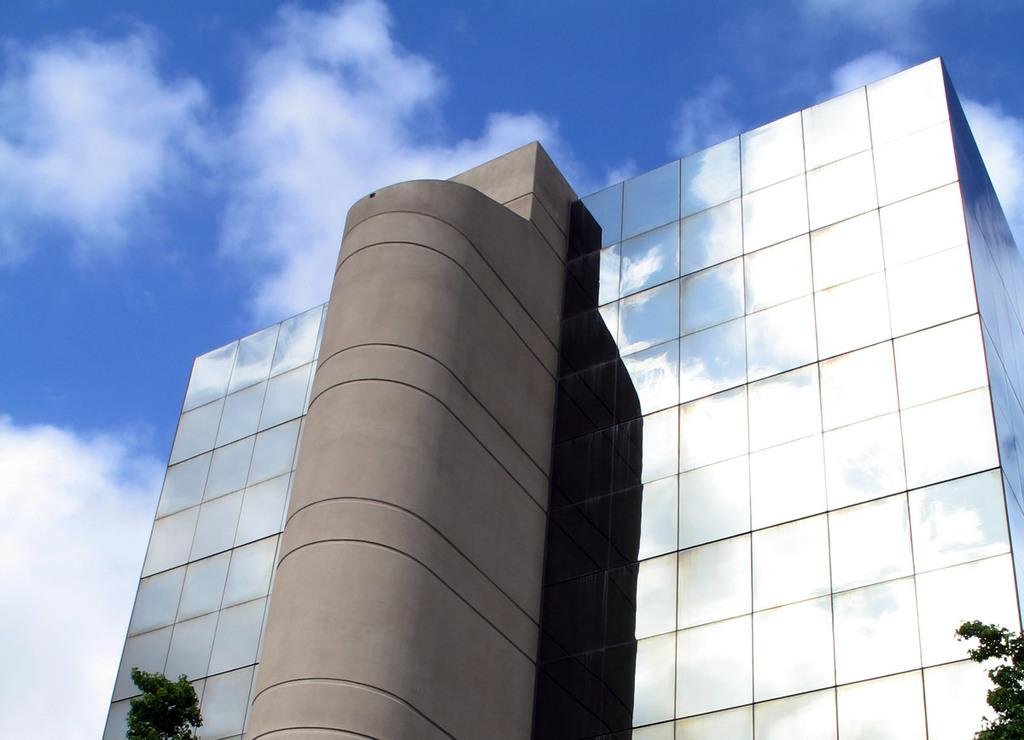What type of structure is present in the image? There is a building in the image. What other natural elements can be seen in the image? There are trees in the image. What is visible in the background of the image? The sky is visible in the image. Can you describe the sky in the image? There are clouds in the sky in the image. Is there a stream of water flowing through the building in the image? No, there is no stream of water visible in the image. 